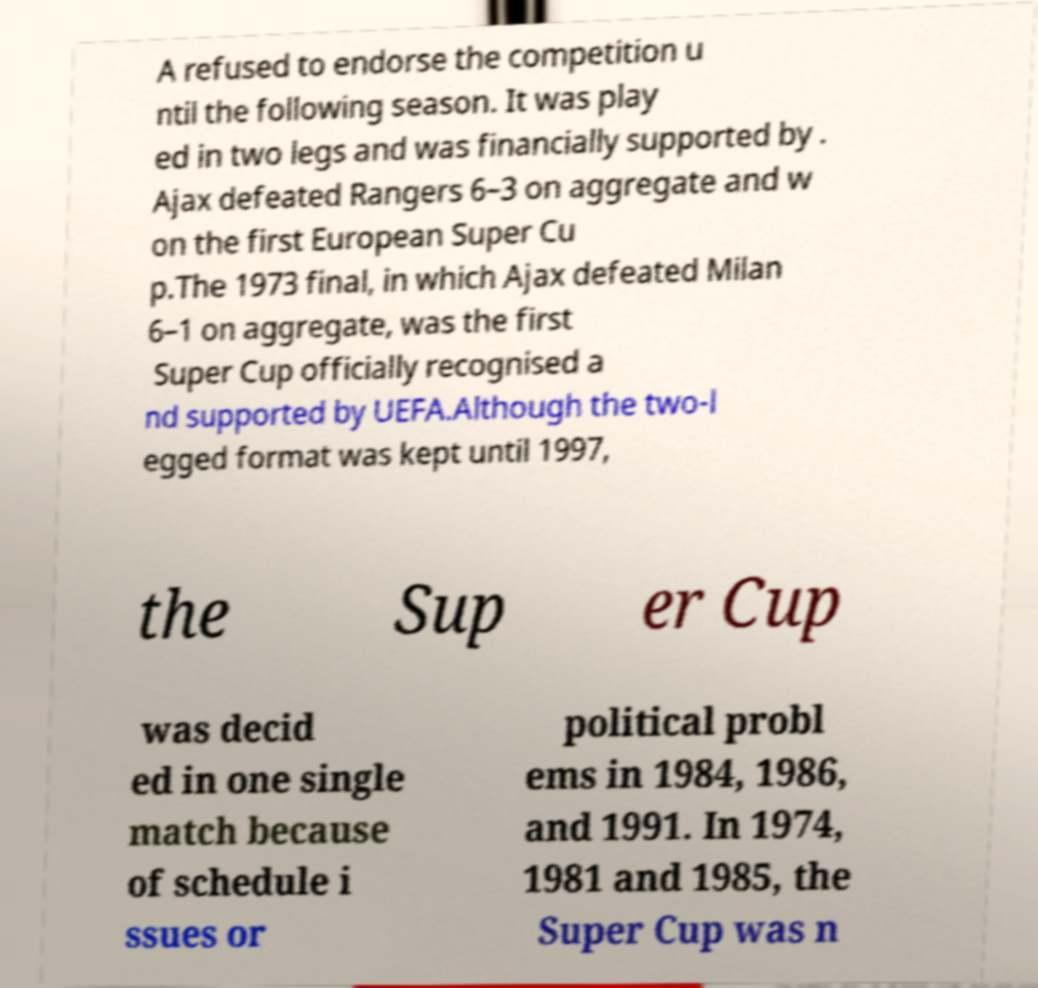Can you read and provide the text displayed in the image?This photo seems to have some interesting text. Can you extract and type it out for me? A refused to endorse the competition u ntil the following season. It was play ed in two legs and was financially supported by . Ajax defeated Rangers 6–3 on aggregate and w on the first European Super Cu p.The 1973 final, in which Ajax defeated Milan 6–1 on aggregate, was the first Super Cup officially recognised a nd supported by UEFA.Although the two-l egged format was kept until 1997, the Sup er Cup was decid ed in one single match because of schedule i ssues or political probl ems in 1984, 1986, and 1991. In 1974, 1981 and 1985, the Super Cup was n 